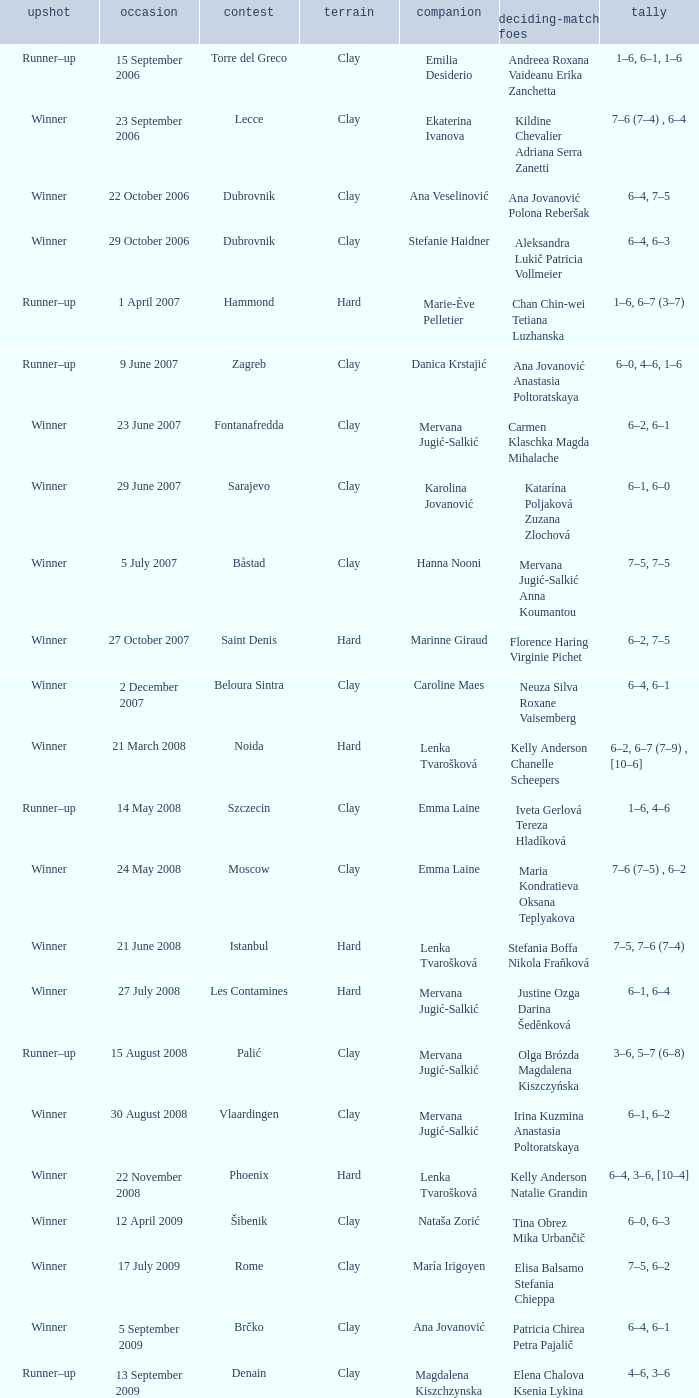Which tournament had a partner of Erika Sema? Aschaffenburg. 